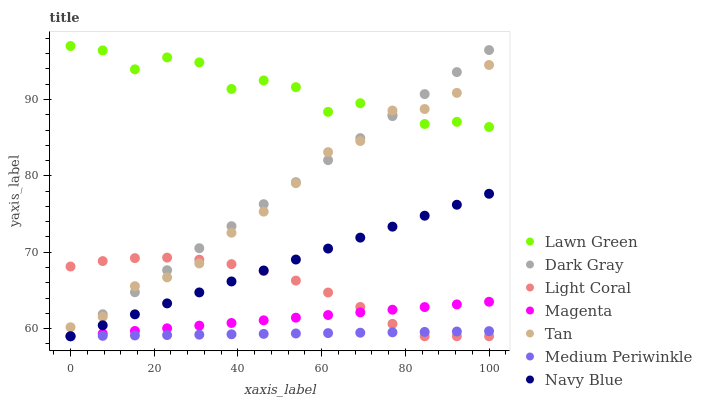Does Medium Periwinkle have the minimum area under the curve?
Answer yes or no. Yes. Does Lawn Green have the maximum area under the curve?
Answer yes or no. Yes. Does Navy Blue have the minimum area under the curve?
Answer yes or no. No. Does Navy Blue have the maximum area under the curve?
Answer yes or no. No. Is Magenta the smoothest?
Answer yes or no. Yes. Is Lawn Green the roughest?
Answer yes or no. Yes. Is Navy Blue the smoothest?
Answer yes or no. No. Is Navy Blue the roughest?
Answer yes or no. No. Does Navy Blue have the lowest value?
Answer yes or no. Yes. Does Tan have the lowest value?
Answer yes or no. No. Does Lawn Green have the highest value?
Answer yes or no. Yes. Does Navy Blue have the highest value?
Answer yes or no. No. Is Navy Blue less than Tan?
Answer yes or no. Yes. Is Lawn Green greater than Medium Periwinkle?
Answer yes or no. Yes. Does Magenta intersect Light Coral?
Answer yes or no. Yes. Is Magenta less than Light Coral?
Answer yes or no. No. Is Magenta greater than Light Coral?
Answer yes or no. No. Does Navy Blue intersect Tan?
Answer yes or no. No. 